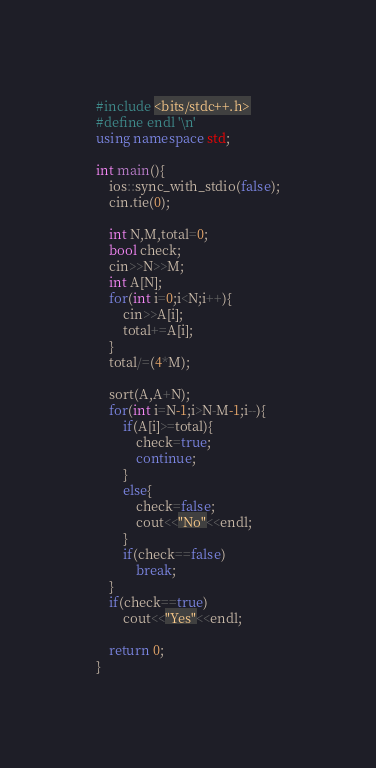Convert code to text. <code><loc_0><loc_0><loc_500><loc_500><_C++_>#include <bits/stdc++.h>
#define endl '\n'
using namespace std;

int main(){
	ios::sync_with_stdio(false);
	cin.tie(0);
	
	int N,M,total=0;
	bool check;
	cin>>N>>M;
	int A[N];
	for(int i=0;i<N;i++){
		cin>>A[i];
		total+=A[i];
	}
	total/=(4*M);
	
	sort(A,A+N);
	for(int i=N-1;i>N-M-1;i--){
		if(A[i]>=total){
			check=true;
			continue;
		}
		else{
			check=false;
			cout<<"No"<<endl;
		}
		if(check==false)
			break;
	}
	if(check==true)
		cout<<"Yes"<<endl;
	
	return 0;
}</code> 